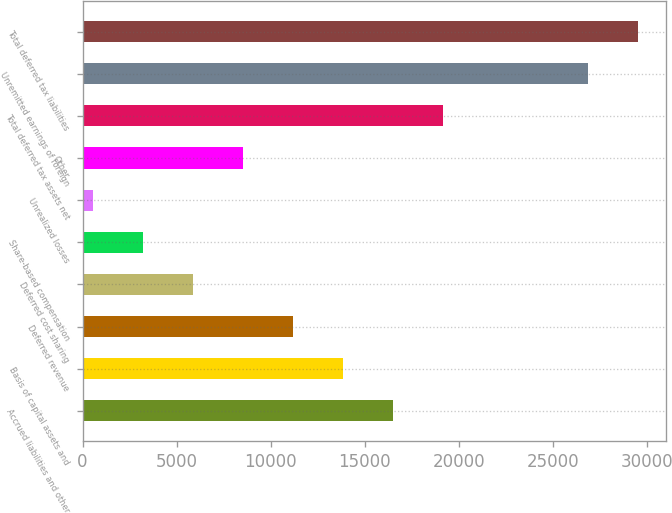Convert chart to OTSL. <chart><loc_0><loc_0><loc_500><loc_500><bar_chart><fcel>Accrued liabilities and other<fcel>Basis of capital assets and<fcel>Deferred revenue<fcel>Deferred cost sharing<fcel>Share-based compensation<fcel>Unrealized losses<fcel>Other<fcel>Total deferred tax assets net<fcel>Unremitted earnings of foreign<fcel>Total deferred tax liabilities<nl><fcel>16528.2<fcel>13867.5<fcel>11206.8<fcel>5885.4<fcel>3224.7<fcel>564<fcel>8546.1<fcel>19188.9<fcel>26868<fcel>29528.7<nl></chart> 